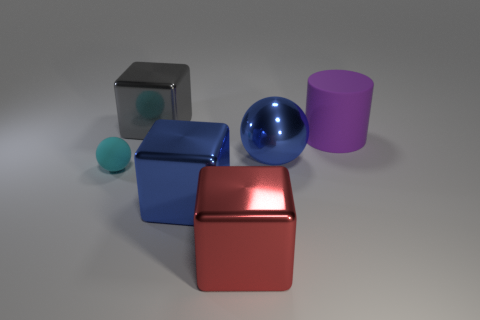What is the color of the ball to the right of the gray object?
Ensure brevity in your answer.  Blue. There is a rubber object that is left of the blue metallic block; are there any large rubber cylinders on the left side of it?
Your response must be concise. No. There is a tiny cyan thing; is its shape the same as the blue object in front of the cyan object?
Your answer should be compact. No. There is a object that is both to the left of the big purple cylinder and behind the large ball; how big is it?
Offer a terse response. Large. Is there a big yellow ball that has the same material as the large red cube?
Ensure brevity in your answer.  No. What size is the metal cube that is the same color as the large shiny ball?
Provide a short and direct response. Large. What is the large block that is behind the rubber object left of the red shiny block made of?
Make the answer very short. Metal. How many large matte objects are the same color as the large cylinder?
Provide a short and direct response. 0. There is a sphere that is the same material as the big purple cylinder; what size is it?
Provide a succinct answer. Small. What is the shape of the object that is behind the purple matte cylinder?
Your answer should be compact. Cube. 